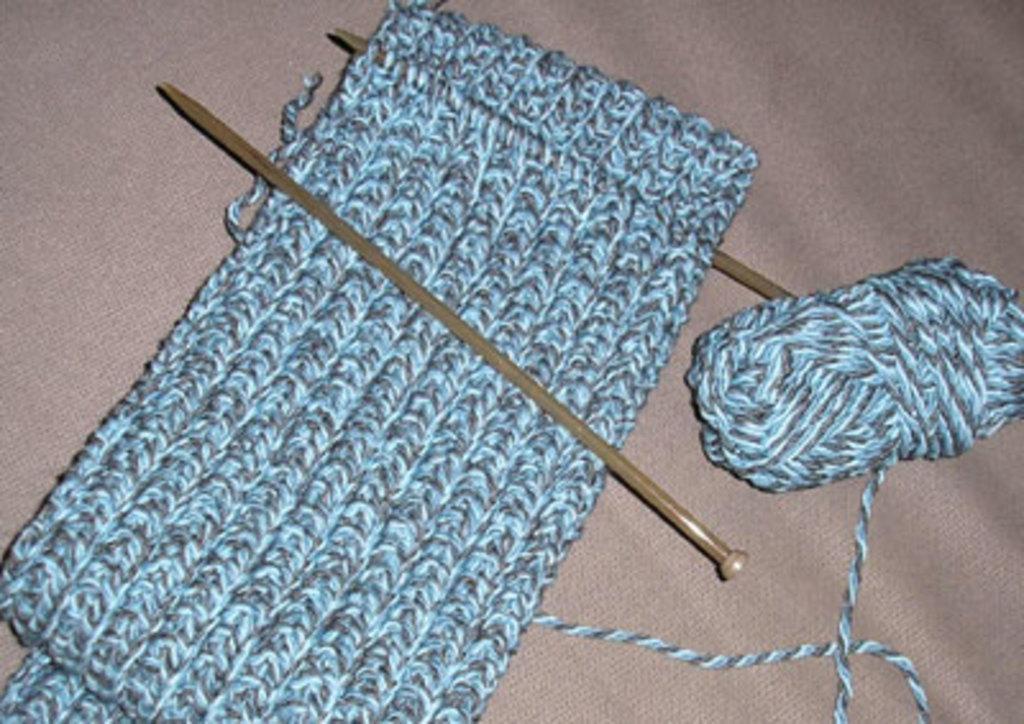Could you give a brief overview of what you see in this image? In the image there is a woolen thread and two needles and there is a cloth prepared with the wooden thread. 